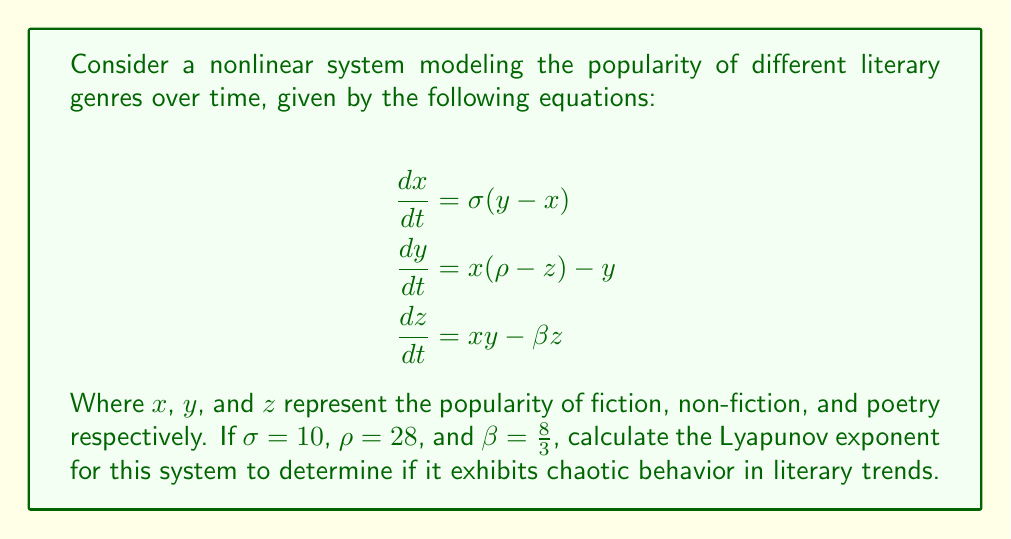Can you solve this math problem? To determine if the system exhibits chaotic behavior, we need to calculate the Lyapunov exponent. The steps are as follows:

1) First, we recognize that this system is the Lorenz system, which is known to exhibit chaotic behavior for certain parameter values.

2) The Lyapunov exponent (λ) measures the rate of separation of infinitesimally close trajectories. For a chaotic system, λ > 0.

3) For the Lorenz system, the Lyapunov exponent can be approximated using the formula:

   $$\lambda \approx \sigma + \rho - \beta - 1$$

4) Substituting the given values:

   $$\lambda \approx 10 + 28 - \frac{8}{3} - 1$$

5) Simplifying:

   $$\lambda \approx 38 - \frac{8}{3} - 1 = 37 - \frac{8}{3} = \frac{111}{3} - \frac{8}{3} = \frac{103}{3} \approx 34.33$$

6) Since λ > 0, the system exhibits chaotic behavior.

This means that small changes in initial conditions can lead to significantly different outcomes in literary trends over time, making long-term predictions difficult. This aligns with the unpredictable nature of literary trends in real life.
Answer: $\lambda \approx \frac{103}{3} \approx 34.33$ (chaotic behavior) 